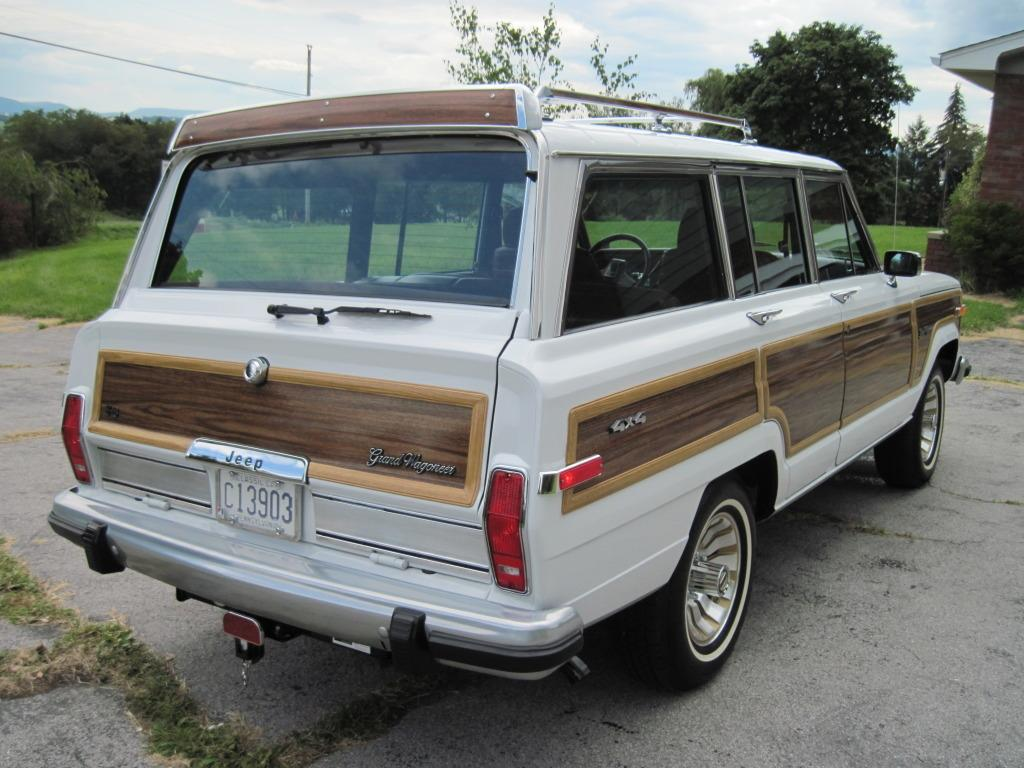What type of natural elements can be seen in the image? There are trees in the image. What is the main subject in the middle of the image? There is a vehicle in the middle of the image. What architectural feature is present in the top right of the image? There is a wall in the top right of the image. What is visible at the top of the image? The sky is visible at the top of the image. Can you tell me how the stranger expresses their love for the stitch in the image? There is no stranger or stitch present in the image; it features trees, a vehicle, a wall, and the sky. 